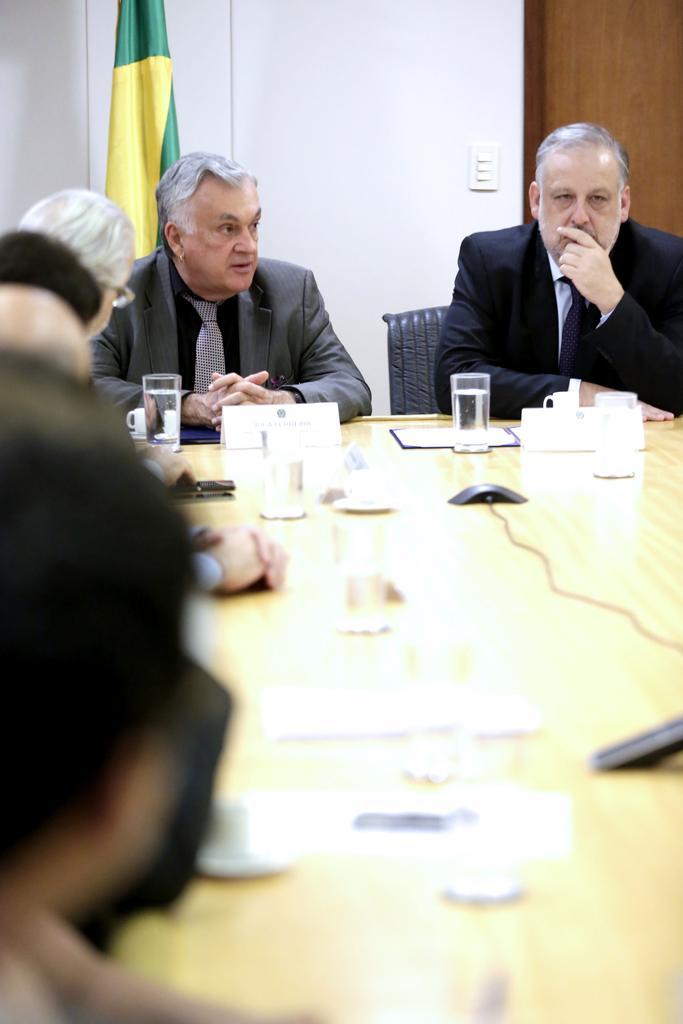How would you summarize this image in a sentence or two? on a table there are glasses, mouse. people are seated around the table on black chairs wearing suit. behind them there is a flag, a white wall and a door at the right. 